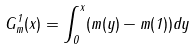Convert formula to latex. <formula><loc_0><loc_0><loc_500><loc_500>G ^ { 1 } _ { m } ( x ) = \int _ { 0 } ^ { x } ( m ( y ) - m ( 1 ) ) d y</formula> 